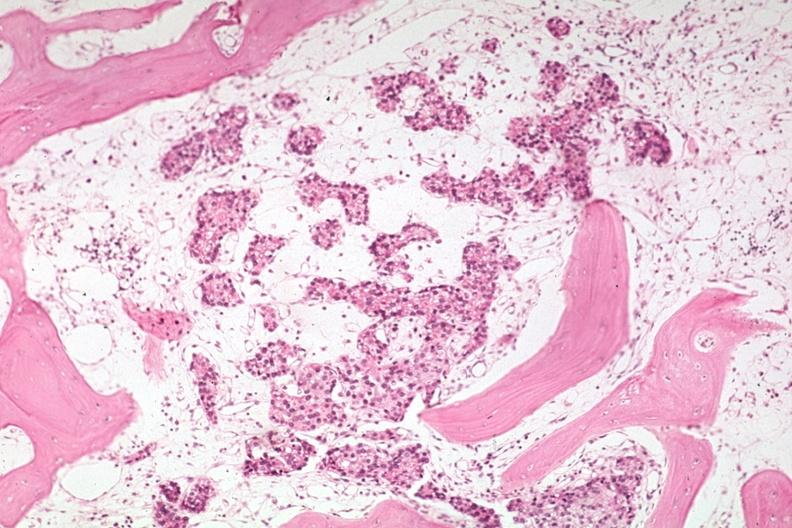what is present?
Answer the question using a single word or phrase. Joints 